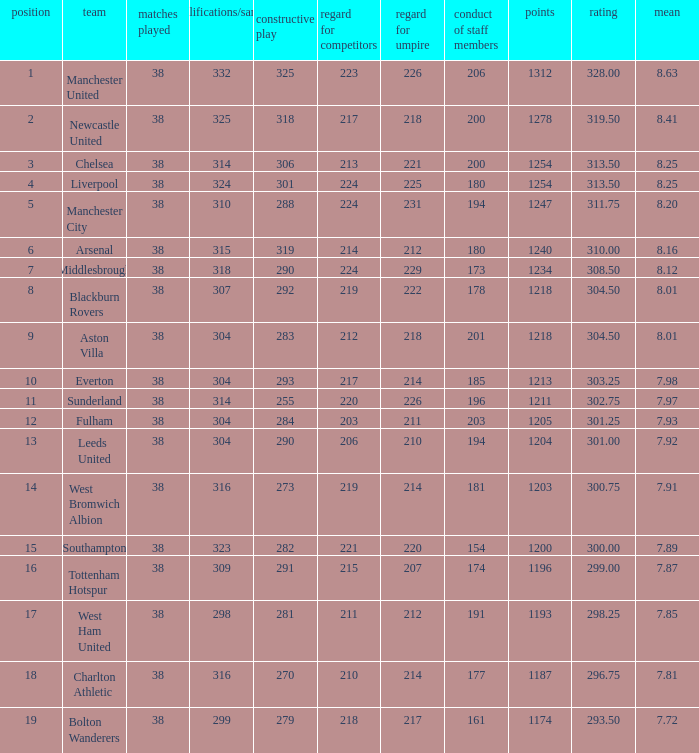Name the points for 212 respect toward opponents 1218.0. 